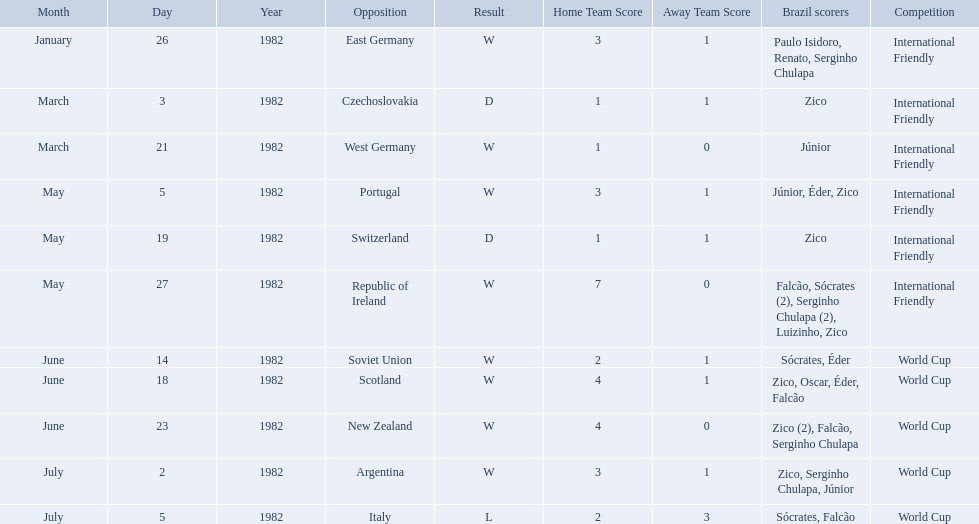What are the dates? January 26, 1982, March 3, 1982, March 21, 1982, May 5, 1982, May 19, 1982, May 27, 1982, June 14, 1982, June 18, 1982, June 23, 1982, July 2, 1982, July 5, 1982. And which date is listed first? January 26, 1982. What are the dates January 26, 1982, March 3, 1982, March 21, 1982, May 5, 1982, May 19, 1982, May 27, 1982, June 14, 1982, June 18, 1982, June 23, 1982, July 2, 1982, July 5, 1982. Which date is at the top? January 26, 1982. Who did brazil play against Soviet Union. Who scored the most goals? Portugal. What were the scores of each of game in the 1982 brazilian football games? 3-1, 1-1, 1-0, 3-1, 1-1, 7-0, 2-1, 4-1, 4-0, 3-1, 2-3. Of those, which were scores from games against portugal and the soviet union? 3-1, 2-1. And between those two games, against which country did brazil score more goals? Portugal. How many goals did brazil score against the soviet union? 2-1. How many goals did brazil score against portugal? 3-1. Did brazil score more goals against portugal or the soviet union? Portugal. 